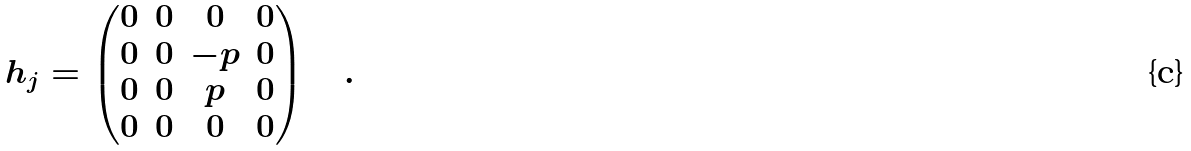<formula> <loc_0><loc_0><loc_500><loc_500>h _ { j } = \begin{pmatrix} 0 & 0 & 0 & 0 \\ 0 & 0 & - p & 0 \\ 0 & 0 & p & 0 \\ 0 & 0 & 0 & 0 \end{pmatrix} \quad .</formula> 